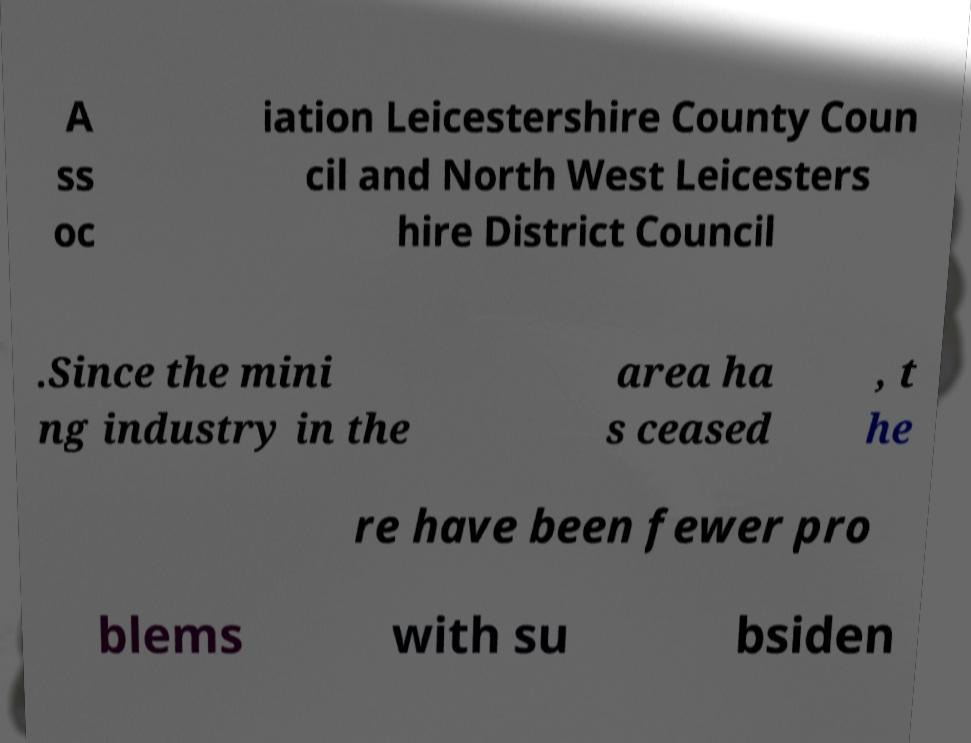What messages or text are displayed in this image? I need them in a readable, typed format. A ss oc iation Leicestershire County Coun cil and North West Leicesters hire District Council .Since the mini ng industry in the area ha s ceased , t he re have been fewer pro blems with su bsiden 